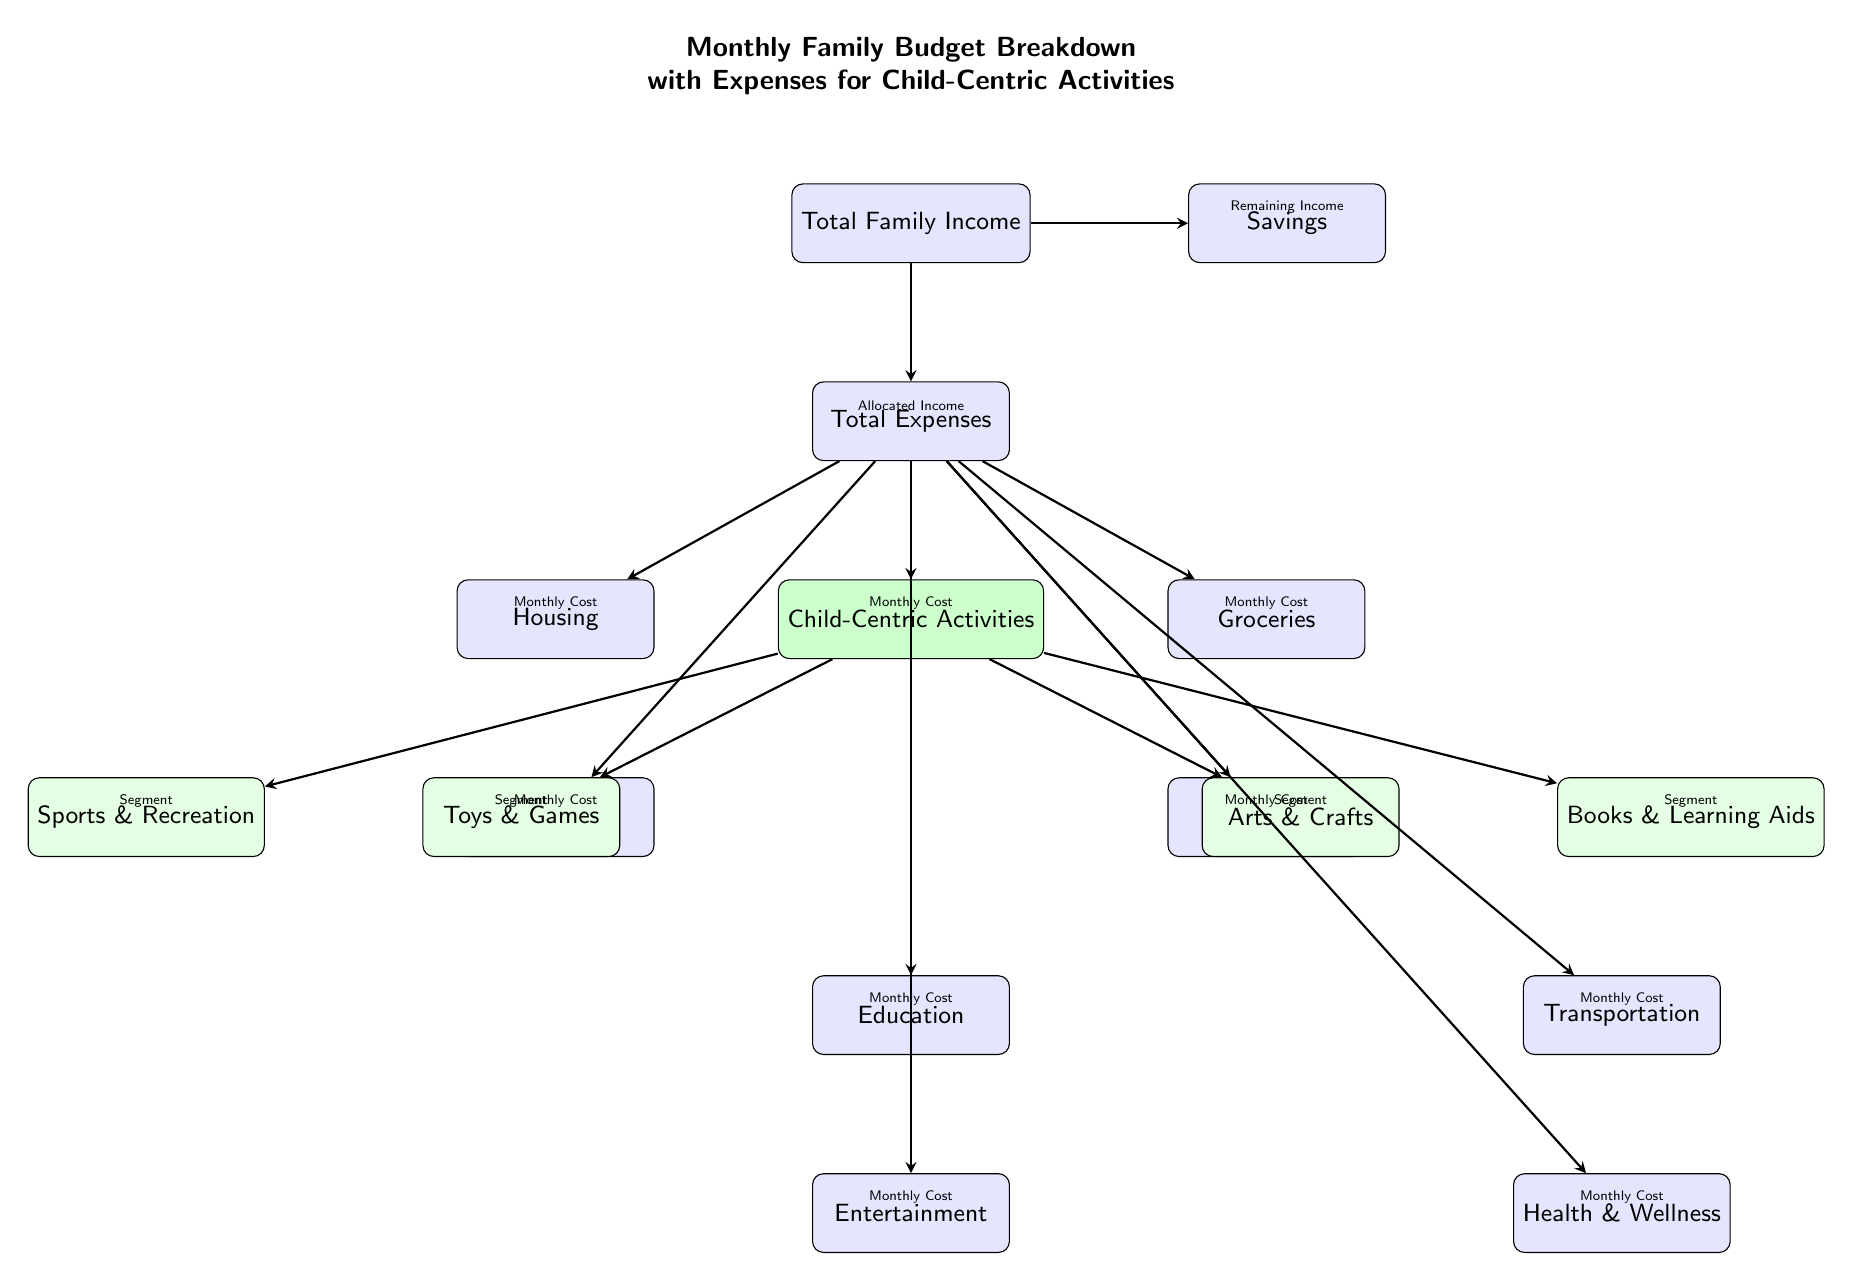What is the primary focus of the diagram? The diagram focuses on the monthly family budget and categorizes the expenses associated with child-centric activities within the family budget framework.
Answer: Monthly Family Budget Breakdown How many main expense categories are represented in the diagram? There are 8 main expense categories illustrated in the diagram: Housing, Utilities, Groceries, Childcare, Education, Transportation, Entertainment, and Health & Wellness.
Answer: 8 Which node represents the total allocated income? The "Total Expenses" node represents the total allocated income, as it is directly linked from the "Total Family Income" indicating the monthly budget allocation.
Answer: Total Expenses What are the four child-centric activities listed? The child-centric activities listed in the diagram include Toys & Games, Arts & Crafts, Sports & Recreation, and Books & Learning Aids.
Answer: Toys & Games, Arts & Crafts, Sports & Recreation, Books & Learning Aids Which two categories fall directly under Childcare? The two categories that fall directly under Childcare are Education and Transportation, as they are positioned below Childcare, indicating their relationship as expenses related to caring for children.
Answer: Education, Transportation If you allocate 100% of the family income to expenses, what is the relationship between total income and total expenses? The relationship depicted is that the total income is entirely allocated to the total expenses, meaning there is no leftover income contributing to savings when expenses equal income.
Answer: Remaining Income is 0 How are child-centric activities distinguished in the diagram? Child-centric activities are distinguished by a green background fill, which visually separates them from other expense categories, highlighting their significance in the budget.
Answer: Green background fill Which category is positioned highest in the diagram? The category positioned highest is "Total Family Income," which represents the starting point of the budget breakdown, from which all expenses and savings flow.
Answer: Total Family Income 